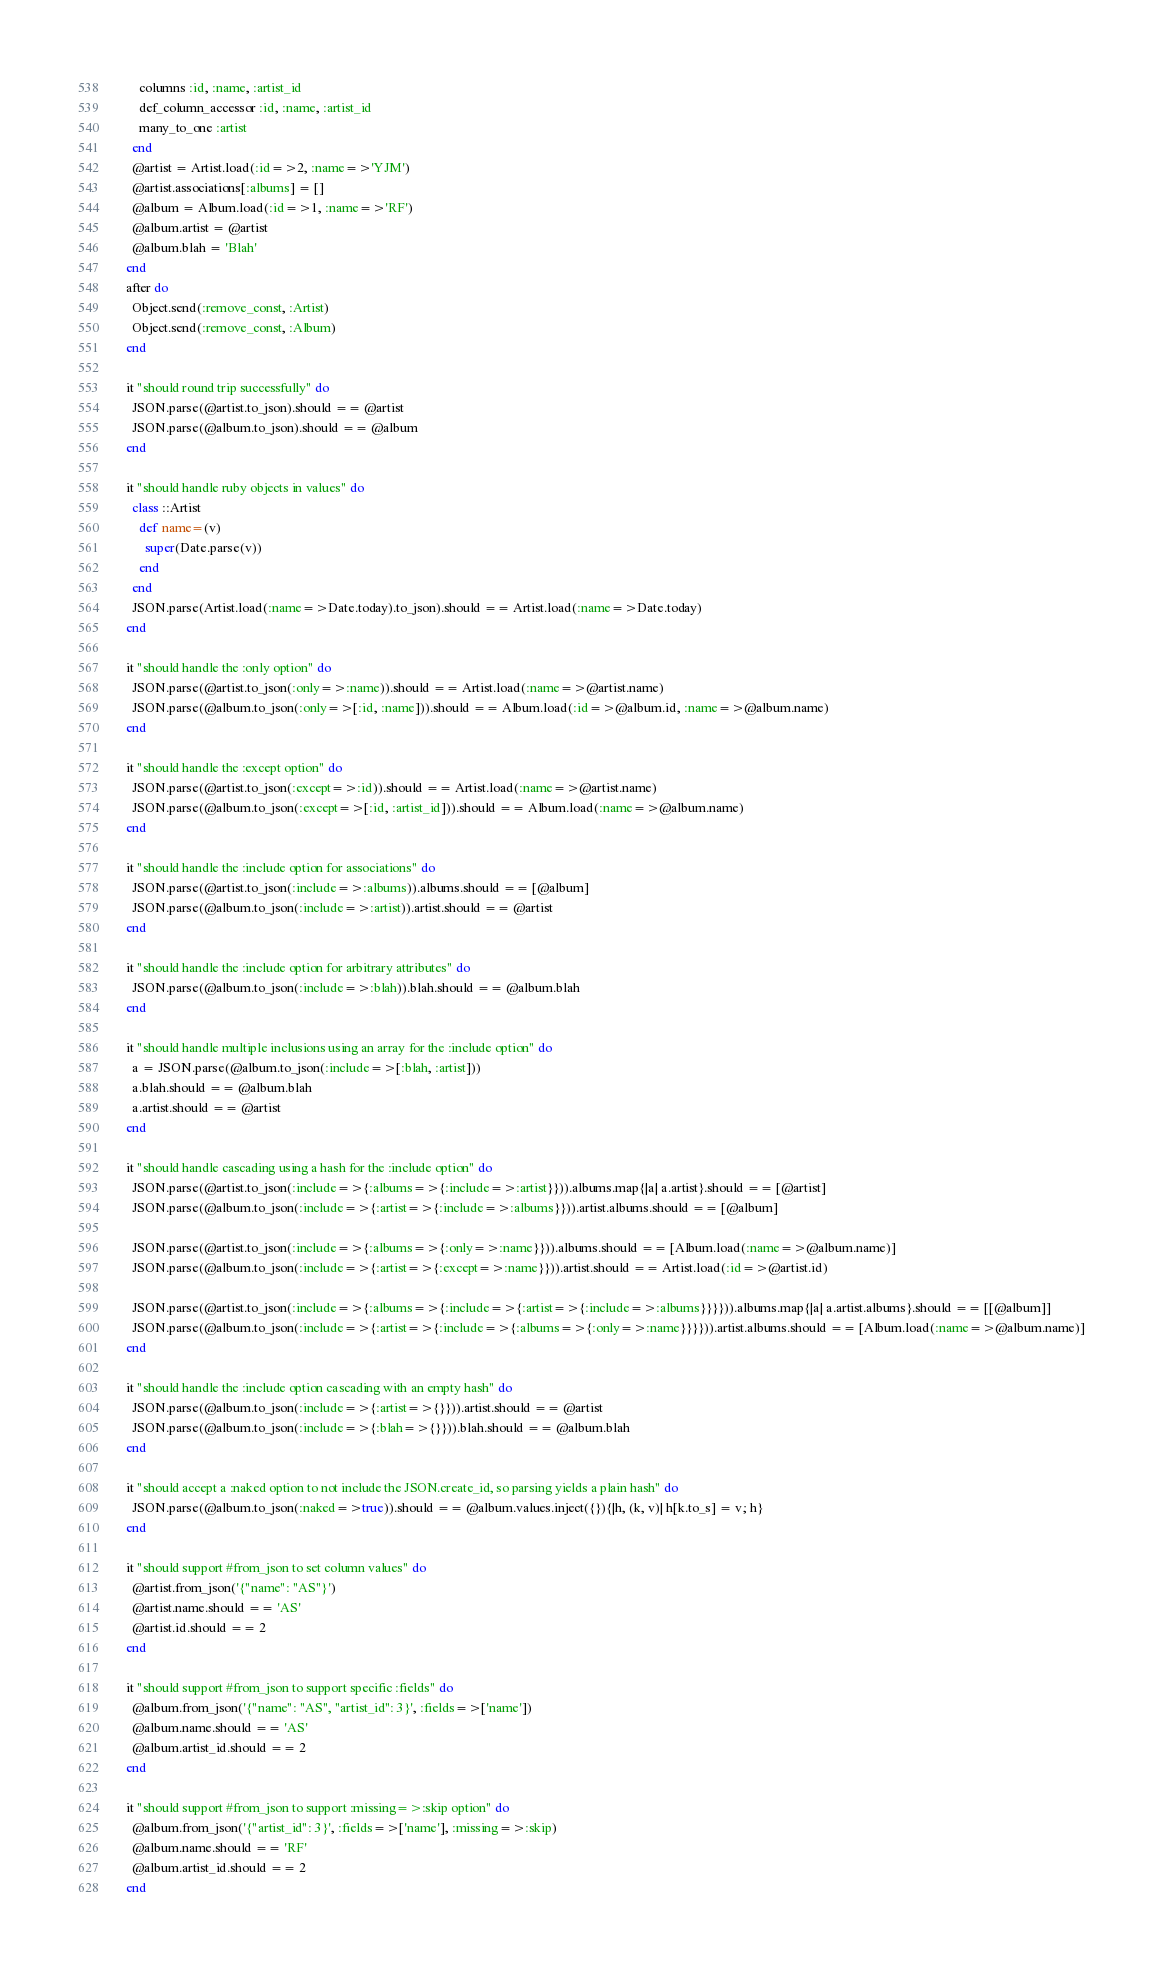Convert code to text. <code><loc_0><loc_0><loc_500><loc_500><_Ruby_>      columns :id, :name, :artist_id
      def_column_accessor :id, :name, :artist_id
      many_to_one :artist
    end
    @artist = Artist.load(:id=>2, :name=>'YJM')
    @artist.associations[:albums] = []
    @album = Album.load(:id=>1, :name=>'RF')
    @album.artist = @artist
    @album.blah = 'Blah'
  end
  after do
    Object.send(:remove_const, :Artist)
    Object.send(:remove_const, :Album)
  end

  it "should round trip successfully" do
    JSON.parse(@artist.to_json).should == @artist
    JSON.parse(@album.to_json).should == @album
  end

  it "should handle ruby objects in values" do
    class ::Artist
      def name=(v)
        super(Date.parse(v))
      end
    end
    JSON.parse(Artist.load(:name=>Date.today).to_json).should == Artist.load(:name=>Date.today)
  end

  it "should handle the :only option" do
    JSON.parse(@artist.to_json(:only=>:name)).should == Artist.load(:name=>@artist.name)
    JSON.parse(@album.to_json(:only=>[:id, :name])).should == Album.load(:id=>@album.id, :name=>@album.name)
  end

  it "should handle the :except option" do
    JSON.parse(@artist.to_json(:except=>:id)).should == Artist.load(:name=>@artist.name)
    JSON.parse(@album.to_json(:except=>[:id, :artist_id])).should == Album.load(:name=>@album.name)
  end

  it "should handle the :include option for associations" do
    JSON.parse(@artist.to_json(:include=>:albums)).albums.should == [@album]
    JSON.parse(@album.to_json(:include=>:artist)).artist.should == @artist
  end

  it "should handle the :include option for arbitrary attributes" do
    JSON.parse(@album.to_json(:include=>:blah)).blah.should == @album.blah
  end

  it "should handle multiple inclusions using an array for the :include option" do
    a = JSON.parse(@album.to_json(:include=>[:blah, :artist]))
    a.blah.should == @album.blah
    a.artist.should == @artist
  end

  it "should handle cascading using a hash for the :include option" do
    JSON.parse(@artist.to_json(:include=>{:albums=>{:include=>:artist}})).albums.map{|a| a.artist}.should == [@artist]
    JSON.parse(@album.to_json(:include=>{:artist=>{:include=>:albums}})).artist.albums.should == [@album]

    JSON.parse(@artist.to_json(:include=>{:albums=>{:only=>:name}})).albums.should == [Album.load(:name=>@album.name)]
    JSON.parse(@album.to_json(:include=>{:artist=>{:except=>:name}})).artist.should == Artist.load(:id=>@artist.id)

    JSON.parse(@artist.to_json(:include=>{:albums=>{:include=>{:artist=>{:include=>:albums}}}})).albums.map{|a| a.artist.albums}.should == [[@album]]
    JSON.parse(@album.to_json(:include=>{:artist=>{:include=>{:albums=>{:only=>:name}}}})).artist.albums.should == [Album.load(:name=>@album.name)]
  end

  it "should handle the :include option cascading with an empty hash" do
    JSON.parse(@album.to_json(:include=>{:artist=>{}})).artist.should == @artist
    JSON.parse(@album.to_json(:include=>{:blah=>{}})).blah.should == @album.blah
  end

  it "should accept a :naked option to not include the JSON.create_id, so parsing yields a plain hash" do
    JSON.parse(@album.to_json(:naked=>true)).should == @album.values.inject({}){|h, (k, v)| h[k.to_s] = v; h}
  end

  it "should support #from_json to set column values" do
    @artist.from_json('{"name": "AS"}')
    @artist.name.should == 'AS'
    @artist.id.should == 2
  end

  it "should support #from_json to support specific :fields" do
    @album.from_json('{"name": "AS", "artist_id": 3}', :fields=>['name'])
    @album.name.should == 'AS'
    @album.artist_id.should == 2
  end

  it "should support #from_json to support :missing=>:skip option" do
    @album.from_json('{"artist_id": 3}', :fields=>['name'], :missing=>:skip)
    @album.name.should == 'RF'
    @album.artist_id.should == 2
  end
</code> 